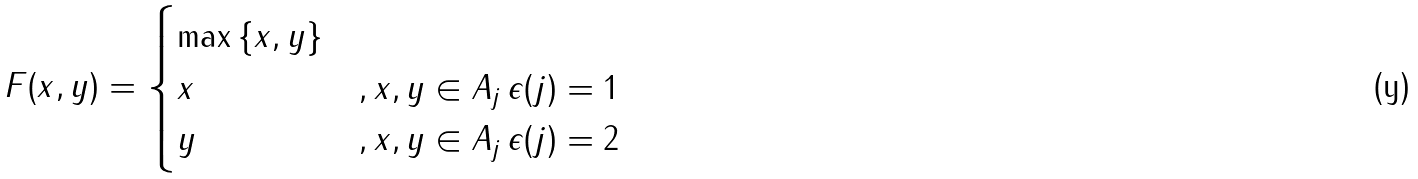Convert formula to latex. <formula><loc_0><loc_0><loc_500><loc_500>F ( x , y ) = \begin{cases} \max { \{ x , y \} } & \\ x & , x , y \in A _ { j } \, \epsilon ( j ) = 1 \\ y & , x , y \in A _ { j } \, \epsilon ( j ) = 2 \end{cases}</formula> 